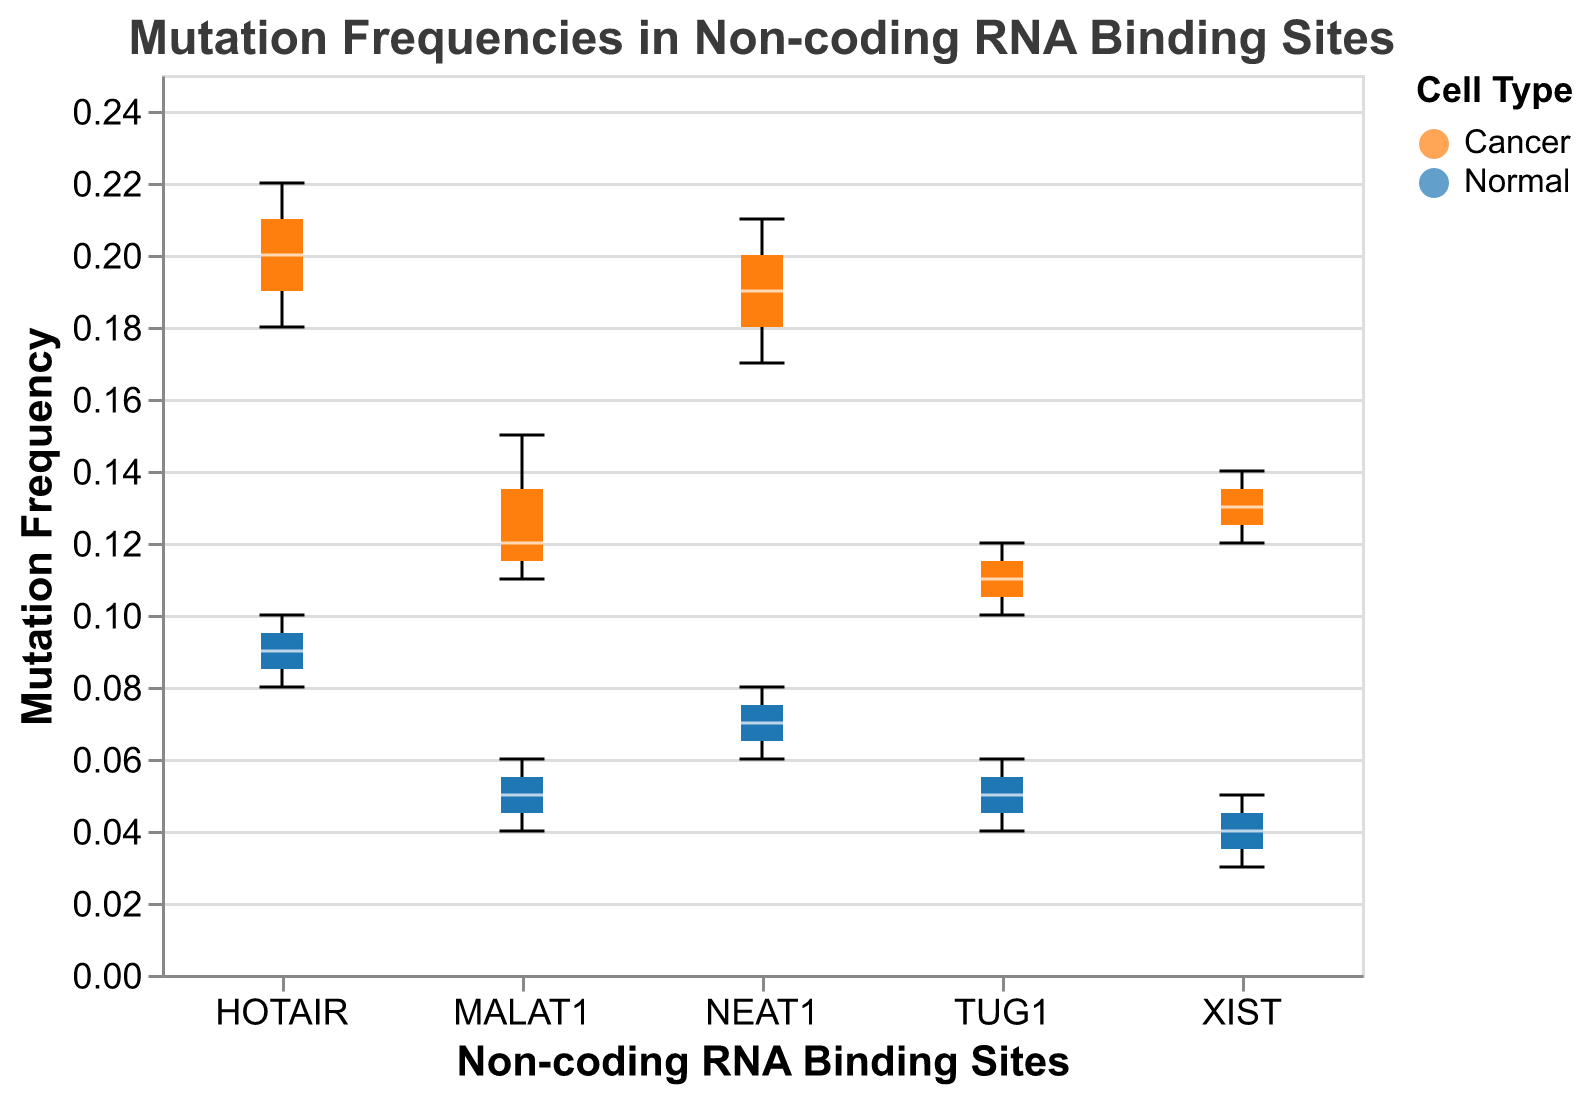What's the title of the plot? The title of the plot is prominently displayed at the top of the figure. It reads "Mutation Frequencies in Non-coding RNA Binding Sites".
Answer: Mutation Frequencies in Non-coding RNA Binding Sites How are the Cancer and Normal cell types differentiated in the plot? The Cancer and Normal cell types are differentiated by color. Cancer is represented by an orange color, and Normal is represented by a blue color, as indicated in the legend.
Answer: Orange for Cancer, Blue for Normal Which non-coding RNA binding site has the highest median mutation frequency in Cancer cells? By identifying the median line within each notched boxplot for Cancer cells (orange), HOTAIR has the highest median mutation frequency as the median line for HOTAIR in Cancer cells is higher than those in other binding sites.
Answer: HOTAIR What is the range of mutation frequencies for MALAT1 in Cancer cells? The boxplot for MALAT1 in Cancer cells shows the minimum and maximum values as the extent of the whiskers. By visual inspection, the range is approximately from 0.11 to 0.15.
Answer: 0.11 to 0.15 Is there any overlap in the interquartile ranges (IQR) of mutation frequencies between Cancer and Normal cells for NEAT1? The plot shows notches around the median lines representing the IQR. For NEAT1, the notches for Cancer (orange) and Normal (blue) cells do not overlap, indicating no overlap in their IQRs.
Answer: No Which non-coding RNA binding sites show higher mutation frequencies in Cancer cells compared to Normal cells? By comparing the median lines or positions of the notched boxplots for Cancer and Normal cells across binding sites, all RNA binding sites (MALAT1, HOTAIR, NEAT1, XIST, TUG1) show higher mutation frequencies in Cancer cells compared to Normal cells.
Answer: All (MALAT1, HOTAIR, NEAT1, XIST, TUG1) What is the difference in the median mutation frequency between Cancer and Normal cells for XIST? The median for Cancer cells (orange) in XIST is around 0.13, and for Normal cells (blue) it is around 0.04. The difference is 0.13 - 0.04.
Answer: 0.09 Which binding site has the smallest variation in mutation frequencies in Normal cells? Variation in mutation frequencies can be observed through the spread of the boxplot. For Normal cells (blue), MALAT1 has the smallest box, indicating the smallest variation.
Answer: MALAT1 Do any binding sites show any outliers in mutation frequency for Cancer cells? Outliers are generally represented as points beyond the whiskers. No points are marked as outliers for Cancer cells in the plot.
Answer: No 